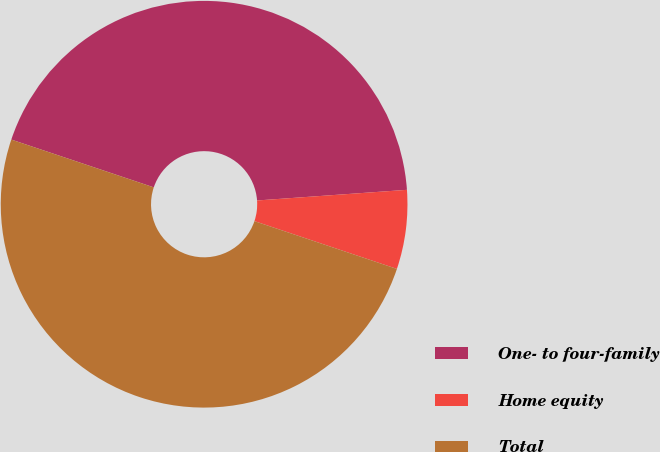Convert chart. <chart><loc_0><loc_0><loc_500><loc_500><pie_chart><fcel>One- to four-family<fcel>Home equity<fcel>Total<nl><fcel>43.72%<fcel>6.28%<fcel>50.0%<nl></chart> 